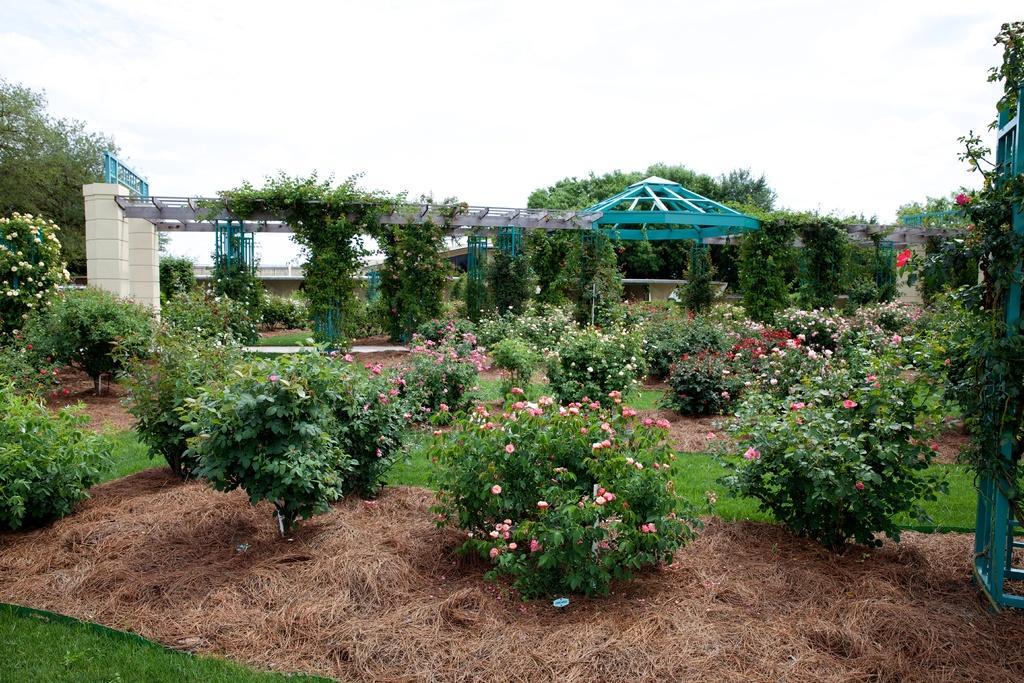Please provide a concise description of this image. In this image we can see trees, plants, grass, creepers, building, arch. In the background there are clouds and sky. 